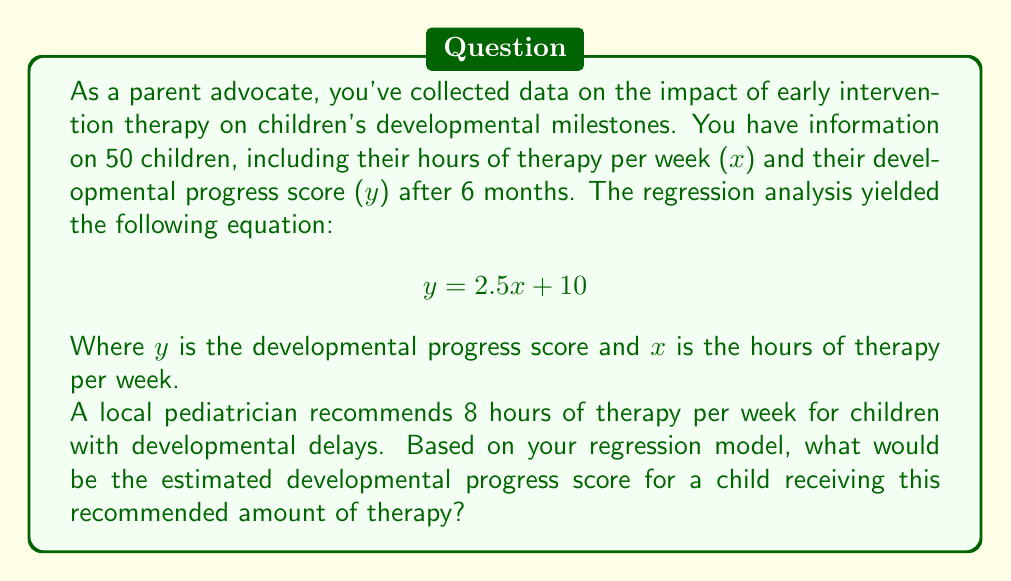Could you help me with this problem? To solve this problem, we need to use the given regression equation and substitute the recommended number of therapy hours:

1. The regression equation is:
   $$ y = 2.5x + 10 $$

2. We are told that the recommended therapy is 8 hours per week, so x = 8.

3. Substitute x = 8 into the equation:
   $$ y = 2.5(8) + 10 $$

4. Simplify:
   $$ y = 20 + 10 $$
   $$ y = 30 $$

Therefore, based on this regression model, a child receiving the recommended 8 hours of therapy per week would be expected to have a developmental progress score of 30 after 6 months.

It's important to note that this is an estimate based on the regression model and individual results may vary. As a parent advocate, you might use this information to discuss the potential benefits of early intervention with other parents, while also emphasizing the importance of individualized care.
Answer: 30 